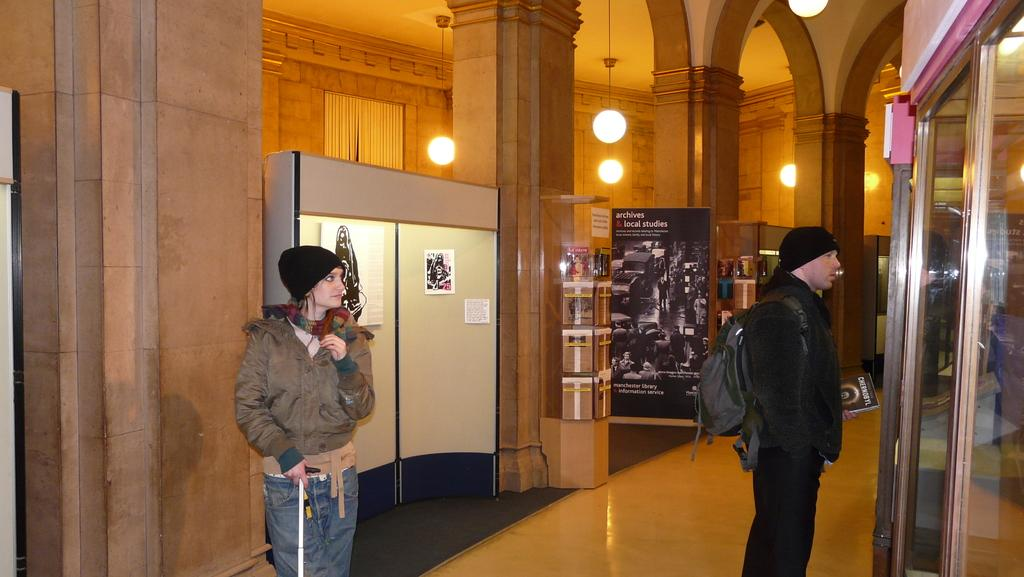How many people are present in the image? There are two persons standing in the image. What is one of the persons holding in the image? There is a person holding a book in the image. What type of objects can be seen in the image? There are boards, papers, lights, and objects in glass boxes in the image. What type of birds can be seen sitting on the sofa in the image? There is no sofa or birds present in the image. How many cattle are visible in the image? There are no cattle present in the image. 